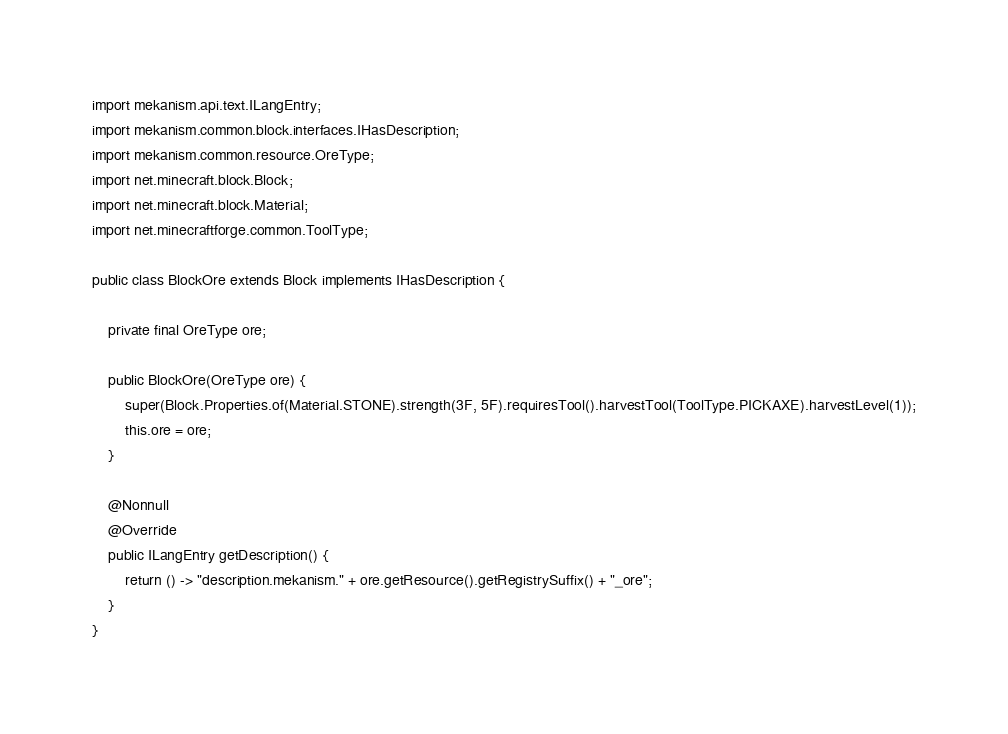<code> <loc_0><loc_0><loc_500><loc_500><_Java_>import mekanism.api.text.ILangEntry;
import mekanism.common.block.interfaces.IHasDescription;
import mekanism.common.resource.OreType;
import net.minecraft.block.Block;
import net.minecraft.block.Material;
import net.minecraftforge.common.ToolType;

public class BlockOre extends Block implements IHasDescription {

    private final OreType ore;

    public BlockOre(OreType ore) {
        super(Block.Properties.of(Material.STONE).strength(3F, 5F).requiresTool().harvestTool(ToolType.PICKAXE).harvestLevel(1));
        this.ore = ore;
    }

    @Nonnull
    @Override
    public ILangEntry getDescription() {
        return () -> "description.mekanism." + ore.getResource().getRegistrySuffix() + "_ore";
    }
}</code> 